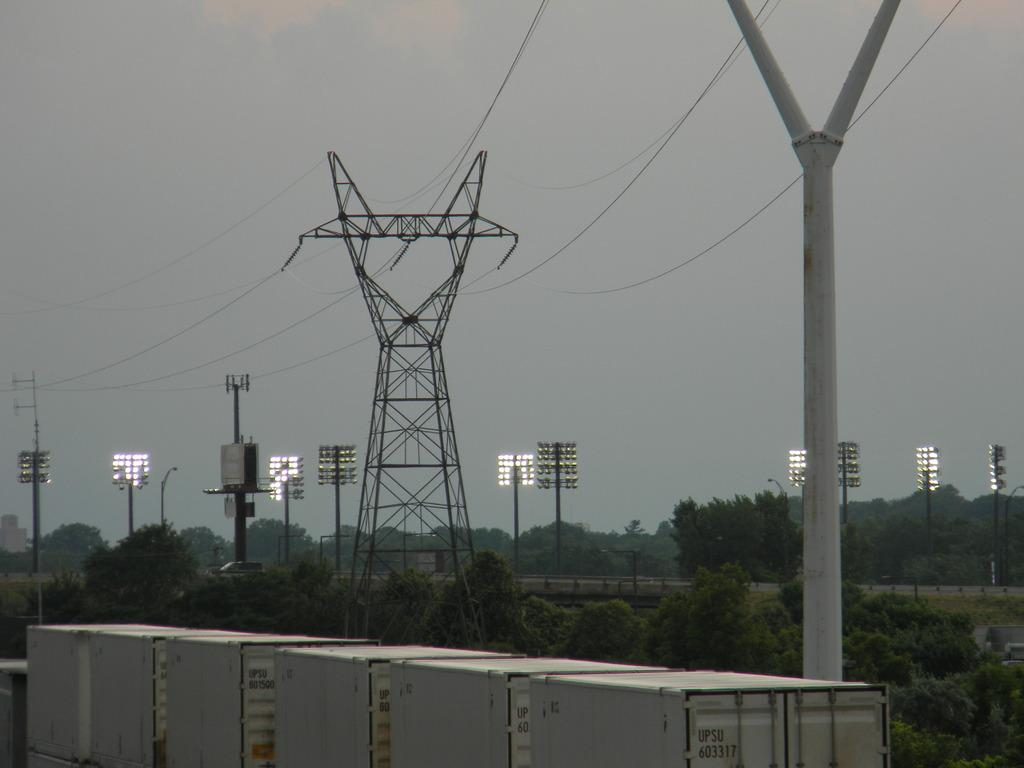What type of natural elements can be seen in the image? There are trees in the image. What type of man-made structures are present in the image? There are poles and lights in the image. What type of infrastructure is visible in the image? There are cables in the image. What other objects can be seen in the image? There are other objects in the image, but their specific nature is not mentioned in the facts. What type of containers are present at the bottom of the image? There are containers at the bottom of the image. What is visible at the top of the image? The sky is visible at the top of the image. What is the name of the son in the image? There is no son present in the image. What type of rail is visible in the image? There is no rail visible in the image. 